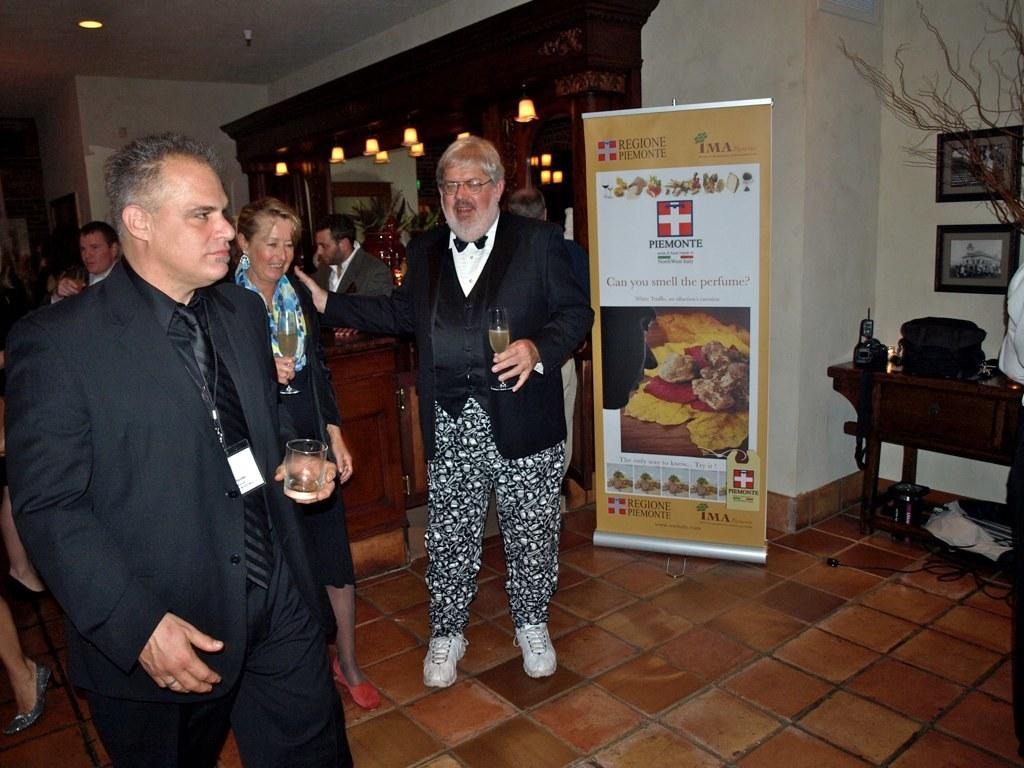What are the men in the image doing? The men in the image are standing and holding a glass of wine. What object can be seen on the table in the image? There is a backpack on the table in the image. What is above the table in the image? There are photo frames above the table in the image. What type of copper material can be seen in the image? There is no copper material present in the image. Is there a carriage visible in the image? No, there is no carriage present in the image. 